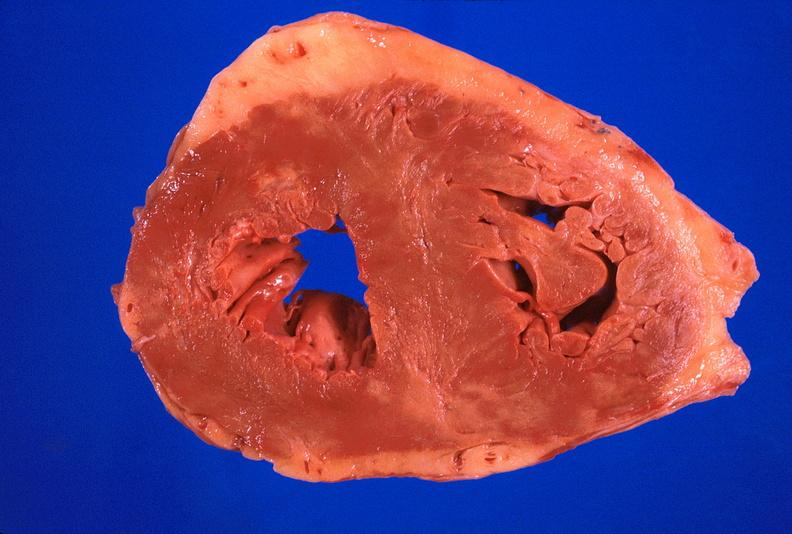what does this image show?
Answer the question using a single word or phrase. Heart 